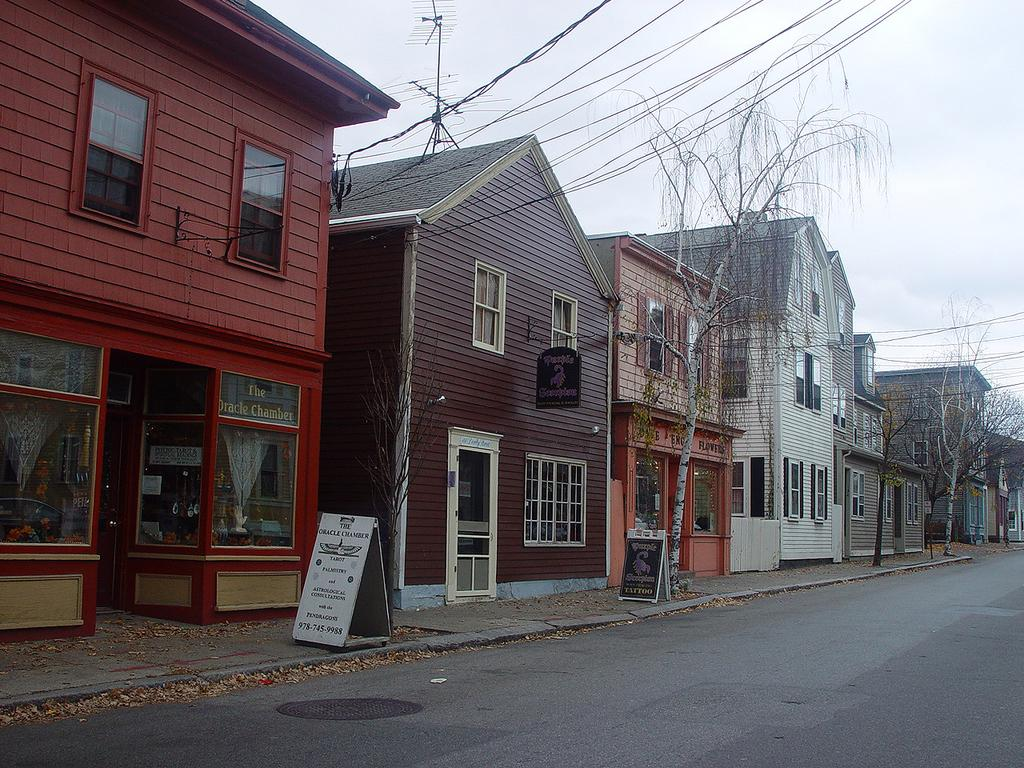What is the main feature of the image? There is a road in the image. What can be found beside the road? Name boards are present beside the road. What else can be seen in the image besides the road and name boards? There are buildings, trees, and wires visible in the image. What is visible in the background of the image? The sky is visible in the background of the image. Can you see the grandmother holding a rifle in the image? There is no grandmother or rifle present in the image. Are there any zebras visible in the image? There are no zebras present in the image. 